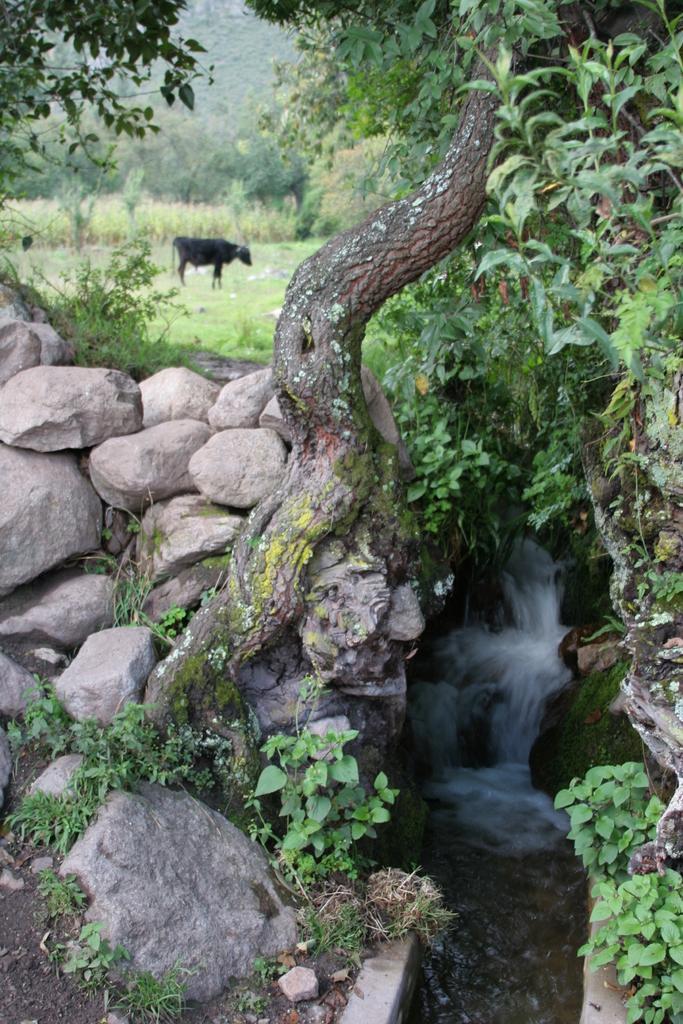How would you summarize this image in a sentence or two? In this image, we can see a tree and some plants. There is a small canal in the bottom right of the image. There is an animal in the bottom right of the image. There are some rocks on the left side of the image. 